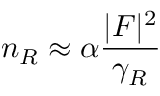Convert formula to latex. <formula><loc_0><loc_0><loc_500><loc_500>n _ { R } \approx \alpha \frac { | F | ^ { 2 } } { \gamma _ { R } }</formula> 